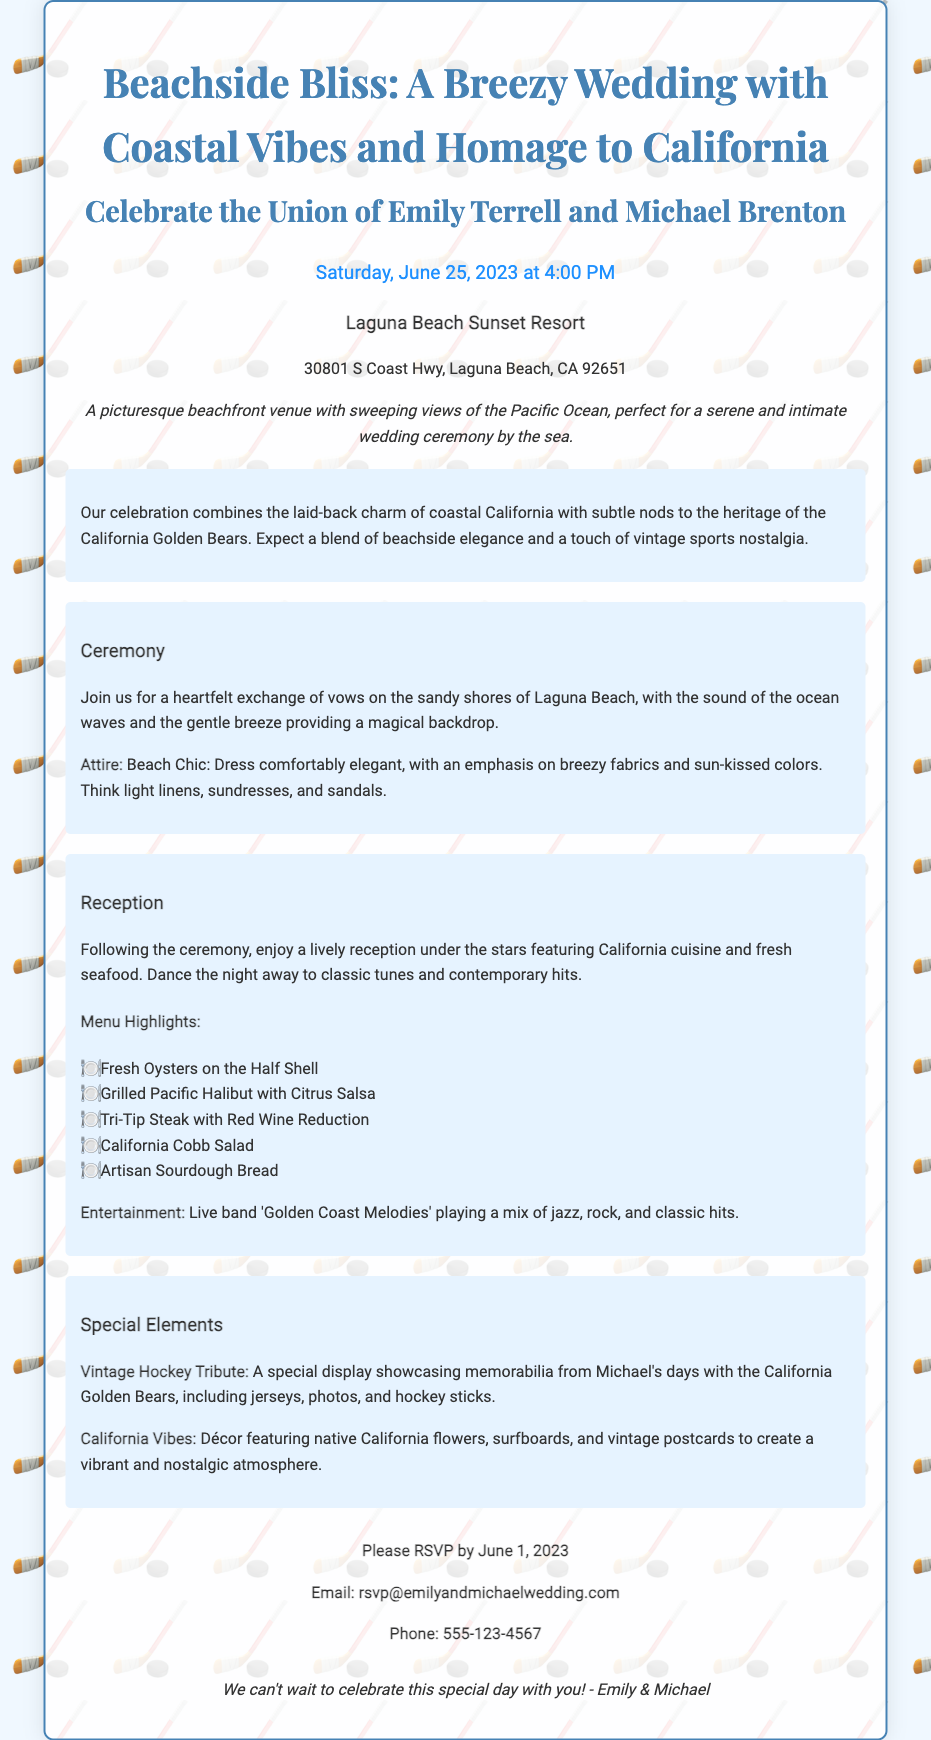What is the name of the bride? The bride's name is mentioned at the beginning of the document.
Answer: Emily Terrell What is the date of the wedding? The date of the wedding is prominently stated in the document.
Answer: June 25, 2023 Where is the wedding venue located? The venue information provides the location of the wedding.
Answer: Laguna Beach Sunset Resort What type of attire is requested for the ceremony? The document specifies the attire for guests attending the ceremony.
Answer: Beach Chic What dish is served as a menu highlight? The document lists multiple menu highlights; one example is requested.
Answer: Fresh Oysters on the Half Shell How should guests RSVP? The RSVP section explains the method for responding to the invitation.
Answer: Email or phone What musical group will perform at the reception? The reception details include the name of the performing band.
Answer: Golden Coast Melodies What special tribute is included in the wedding? The document mentions a specific tribute aspect unique to the groom.
Answer: Vintage Hockey Tribute What overarching theme does the celebration have? The theme combines multiple elements relating to location and heritage.
Answer: Coastal California and California Golden Bears 